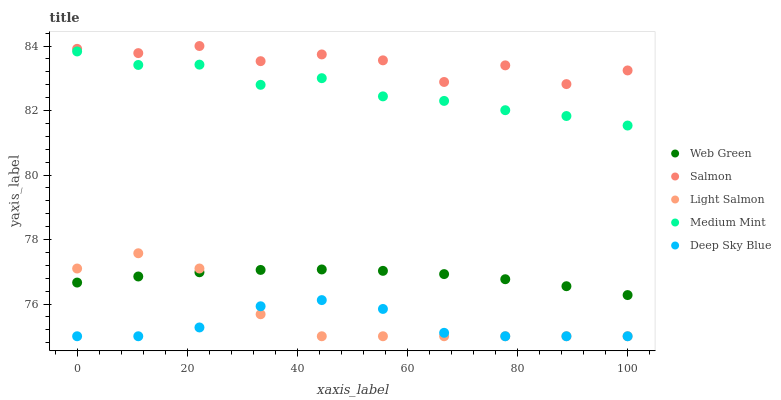Does Deep Sky Blue have the minimum area under the curve?
Answer yes or no. Yes. Does Salmon have the maximum area under the curve?
Answer yes or no. Yes. Does Light Salmon have the minimum area under the curve?
Answer yes or no. No. Does Light Salmon have the maximum area under the curve?
Answer yes or no. No. Is Web Green the smoothest?
Answer yes or no. Yes. Is Salmon the roughest?
Answer yes or no. Yes. Is Light Salmon the smoothest?
Answer yes or no. No. Is Light Salmon the roughest?
Answer yes or no. No. Does Light Salmon have the lowest value?
Answer yes or no. Yes. Does Salmon have the lowest value?
Answer yes or no. No. Does Salmon have the highest value?
Answer yes or no. Yes. Does Light Salmon have the highest value?
Answer yes or no. No. Is Deep Sky Blue less than Web Green?
Answer yes or no. Yes. Is Salmon greater than Light Salmon?
Answer yes or no. Yes. Does Light Salmon intersect Deep Sky Blue?
Answer yes or no. Yes. Is Light Salmon less than Deep Sky Blue?
Answer yes or no. No. Is Light Salmon greater than Deep Sky Blue?
Answer yes or no. No. Does Deep Sky Blue intersect Web Green?
Answer yes or no. No. 